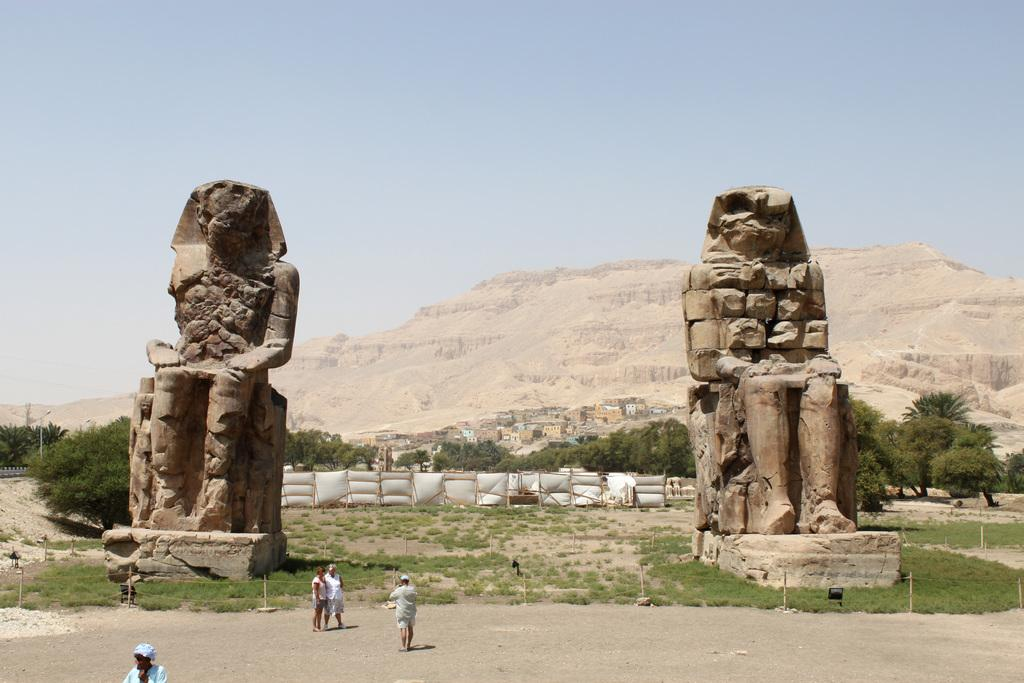What can be seen in the sky in the image? There is sky visible in the image. What type of structures are present in the image? There are pyramids and sculptures in the image. What type of vegetation is visible in the image? There are trees and grass in the image. What is visible on the ground in the image? The ground is visible in the image, and there are poles present as well. Can you describe the waves crashing on the shore in the image? There are no waves or shore visible in the image; it features pyramids, sculptures, trees, grass, and poles. What type of fight is taking place between the two figures in the image? There are no figures or fights depicted in the image; it features pyramids, sculptures, trees, grass, and poles. 